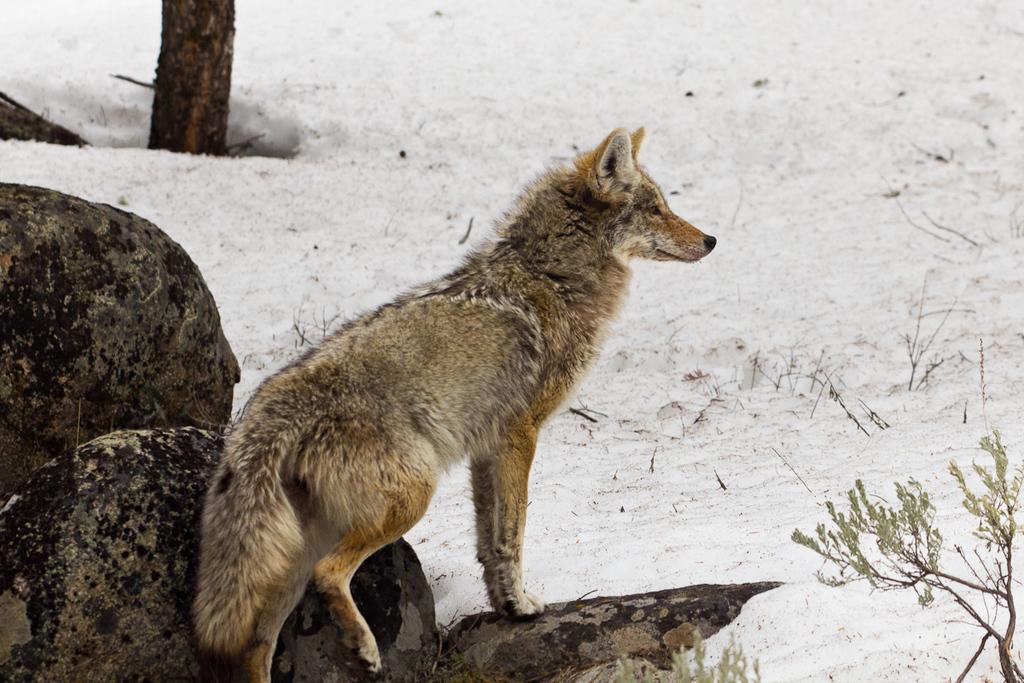Please provide a concise description of this image. In this image we can see an animal standing on a rock, in the background there is a tree, snow and plants. 